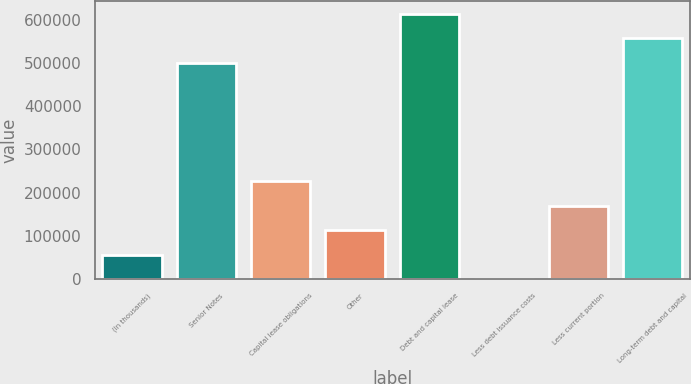Convert chart to OTSL. <chart><loc_0><loc_0><loc_500><loc_500><bar_chart><fcel>(In thousands)<fcel>Senior Notes<fcel>Capital lease obligations<fcel>Other<fcel>Debt and capital lease<fcel>Less debt issuance costs<fcel>Less current portion<fcel>Long-term debt and capital<nl><fcel>56990.9<fcel>500000<fcel>226116<fcel>113366<fcel>612750<fcel>616<fcel>169741<fcel>556375<nl></chart> 